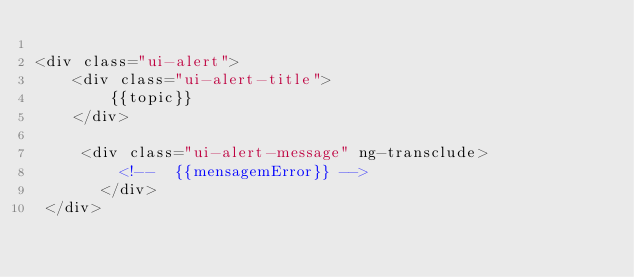Convert code to text. <code><loc_0><loc_0><loc_500><loc_500><_HTML_>
<div class="ui-alert">
    <div class="ui-alert-title">
        {{topic}}
    </div>

     <div class="ui-alert-message" ng-transclude>
         <!--  {{mensagemError}} --> 
       </div>
 </div> </code> 